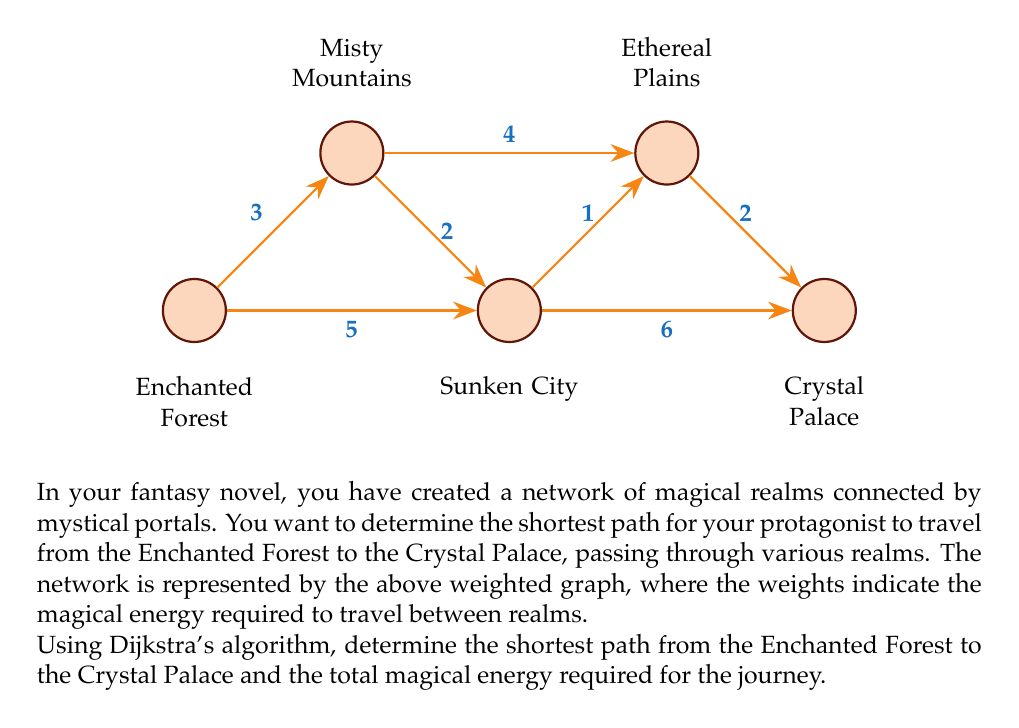Provide a solution to this math problem. To solve this problem, we'll apply Dijkstra's algorithm to find the shortest path from the Enchanted Forest to the Crystal Palace. Let's follow the steps:

1. Initialize:
   - Set distance to Enchanted Forest (EF) as 0 and all others as infinity.
   - Set all nodes as unvisited.
   - Set EF as the current node.

2. For the current node, consider all unvisited neighbors and calculate their tentative distances:
   - EF to Misty Mountains (MM): 0 + 3 = 3
   - EF to Sunken City (SC): 0 + 5 = 5

3. Mark EF as visited. MM has the smallest tentative distance (3), so it becomes the new current node.

4. From MM:
   - MM to SC: min(5, 3 + 2) = 5
   - MM to Ethereal Plains (EP): 3 + 4 = 7

5. Mark MM as visited. SC has the smallest tentative distance (5), so it becomes the new current node.

6. From SC:
   - SC to EP: min(7, 5 + 1) = 6
   - SC to Crystal Palace (CP): 5 + 6 = 11

7. Mark SC as visited. EP has the smallest tentative distance (6), so it becomes the new current node.

8. From EP:
   - EP to CP: min(11, 6 + 2) = 8

9. Mark EP as visited. CP is the only unvisited node left, so we're done.

The shortest path is: Enchanted Forest → Misty Mountains → Sunken City → Ethereal Plains → Crystal Palace

The total magical energy required is 8 units.
Answer: EF → MM → SC → EP → CP, 8 units 